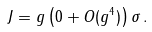<formula> <loc_0><loc_0><loc_500><loc_500>J = g \left ( 0 + O ( g ^ { 4 } ) \right ) \sigma \, .</formula> 